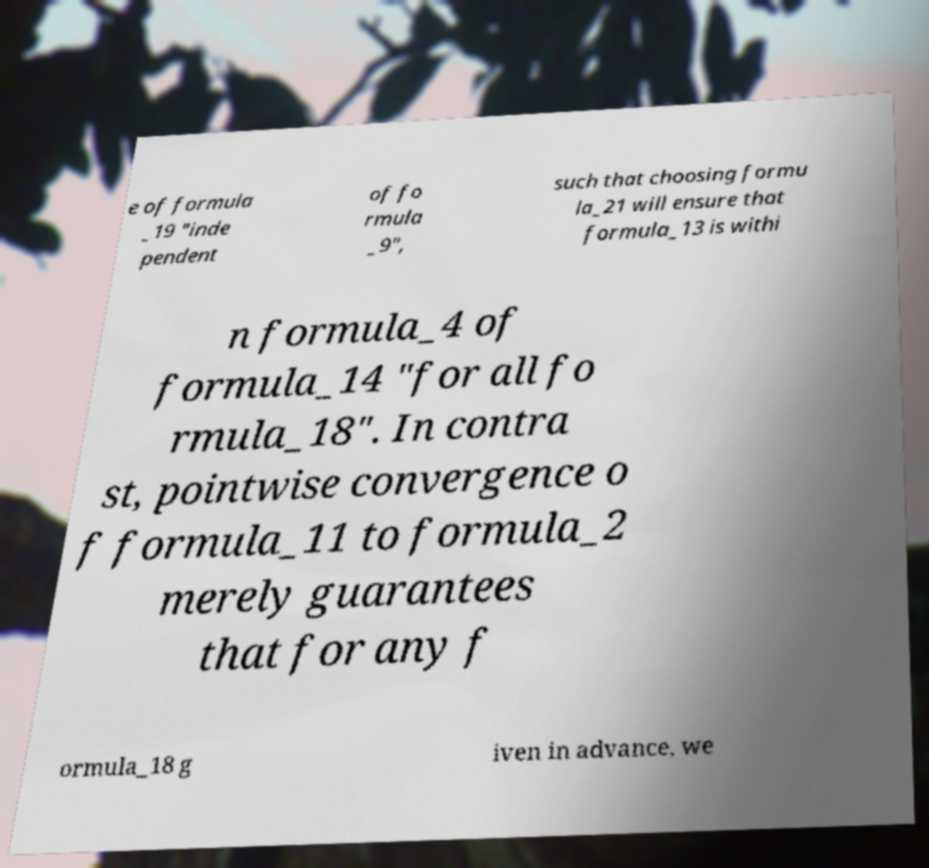There's text embedded in this image that I need extracted. Can you transcribe it verbatim? e of formula _19 "inde pendent of fo rmula _9", such that choosing formu la_21 will ensure that formula_13 is withi n formula_4 of formula_14 "for all fo rmula_18". In contra st, pointwise convergence o f formula_11 to formula_2 merely guarantees that for any f ormula_18 g iven in advance, we 